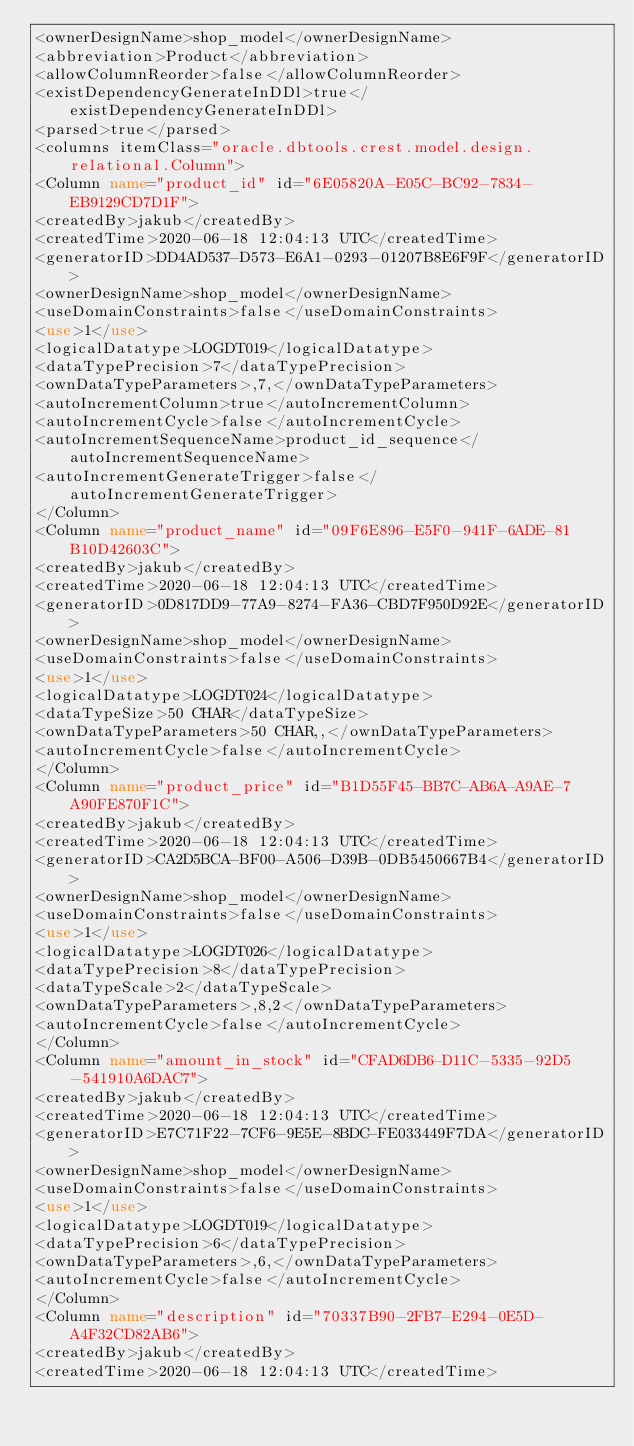<code> <loc_0><loc_0><loc_500><loc_500><_XML_><ownerDesignName>shop_model</ownerDesignName>
<abbreviation>Product</abbreviation>
<allowColumnReorder>false</allowColumnReorder>
<existDependencyGenerateInDDl>true</existDependencyGenerateInDDl>
<parsed>true</parsed>
<columns itemClass="oracle.dbtools.crest.model.design.relational.Column">
<Column name="product_id" id="6E05820A-E05C-BC92-7834-EB9129CD7D1F">
<createdBy>jakub</createdBy>
<createdTime>2020-06-18 12:04:13 UTC</createdTime>
<generatorID>DD4AD537-D573-E6A1-0293-01207B8E6F9F</generatorID>
<ownerDesignName>shop_model</ownerDesignName>
<useDomainConstraints>false</useDomainConstraints>
<use>1</use>
<logicalDatatype>LOGDT019</logicalDatatype>
<dataTypePrecision>7</dataTypePrecision>
<ownDataTypeParameters>,7,</ownDataTypeParameters>
<autoIncrementColumn>true</autoIncrementColumn>
<autoIncrementCycle>false</autoIncrementCycle>
<autoIncrementSequenceName>product_id_sequence</autoIncrementSequenceName>
<autoIncrementGenerateTrigger>false</autoIncrementGenerateTrigger>
</Column>
<Column name="product_name" id="09F6E896-E5F0-941F-6ADE-81B10D42603C">
<createdBy>jakub</createdBy>
<createdTime>2020-06-18 12:04:13 UTC</createdTime>
<generatorID>0D817DD9-77A9-8274-FA36-CBD7F950D92E</generatorID>
<ownerDesignName>shop_model</ownerDesignName>
<useDomainConstraints>false</useDomainConstraints>
<use>1</use>
<logicalDatatype>LOGDT024</logicalDatatype>
<dataTypeSize>50 CHAR</dataTypeSize>
<ownDataTypeParameters>50 CHAR,,</ownDataTypeParameters>
<autoIncrementCycle>false</autoIncrementCycle>
</Column>
<Column name="product_price" id="B1D55F45-BB7C-AB6A-A9AE-7A90FE870F1C">
<createdBy>jakub</createdBy>
<createdTime>2020-06-18 12:04:13 UTC</createdTime>
<generatorID>CA2D5BCA-BF00-A506-D39B-0DB5450667B4</generatorID>
<ownerDesignName>shop_model</ownerDesignName>
<useDomainConstraints>false</useDomainConstraints>
<use>1</use>
<logicalDatatype>LOGDT026</logicalDatatype>
<dataTypePrecision>8</dataTypePrecision>
<dataTypeScale>2</dataTypeScale>
<ownDataTypeParameters>,8,2</ownDataTypeParameters>
<autoIncrementCycle>false</autoIncrementCycle>
</Column>
<Column name="amount_in_stock" id="CFAD6DB6-D11C-5335-92D5-541910A6DAC7">
<createdBy>jakub</createdBy>
<createdTime>2020-06-18 12:04:13 UTC</createdTime>
<generatorID>E7C71F22-7CF6-9E5E-8BDC-FE033449F7DA</generatorID>
<ownerDesignName>shop_model</ownerDesignName>
<useDomainConstraints>false</useDomainConstraints>
<use>1</use>
<logicalDatatype>LOGDT019</logicalDatatype>
<dataTypePrecision>6</dataTypePrecision>
<ownDataTypeParameters>,6,</ownDataTypeParameters>
<autoIncrementCycle>false</autoIncrementCycle>
</Column>
<Column name="description" id="70337B90-2FB7-E294-0E5D-A4F32CD82AB6">
<createdBy>jakub</createdBy>
<createdTime>2020-06-18 12:04:13 UTC</createdTime></code> 